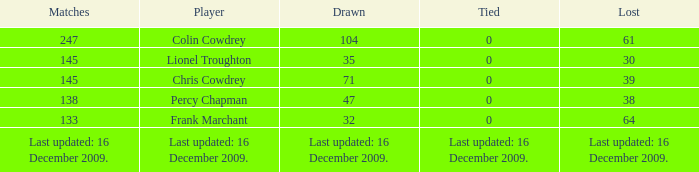I want to know the tie for drawn of 47 0.0. 